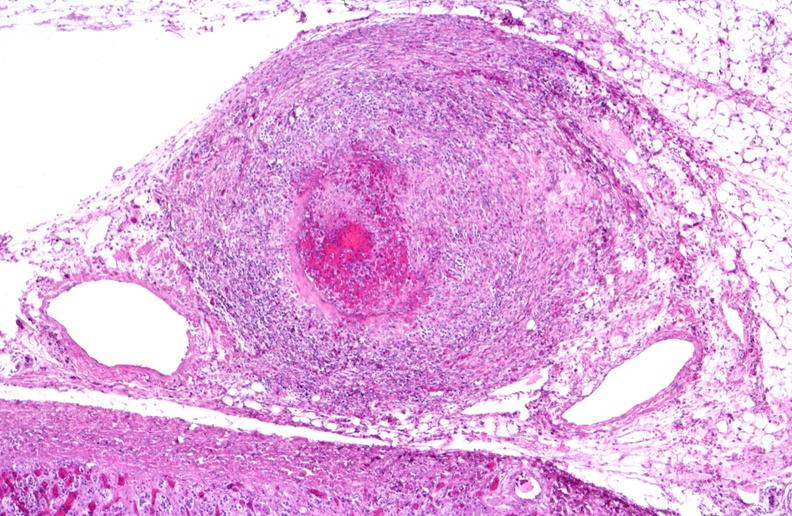does this image show polyarteritis nodosa?
Answer the question using a single word or phrase. Yes 